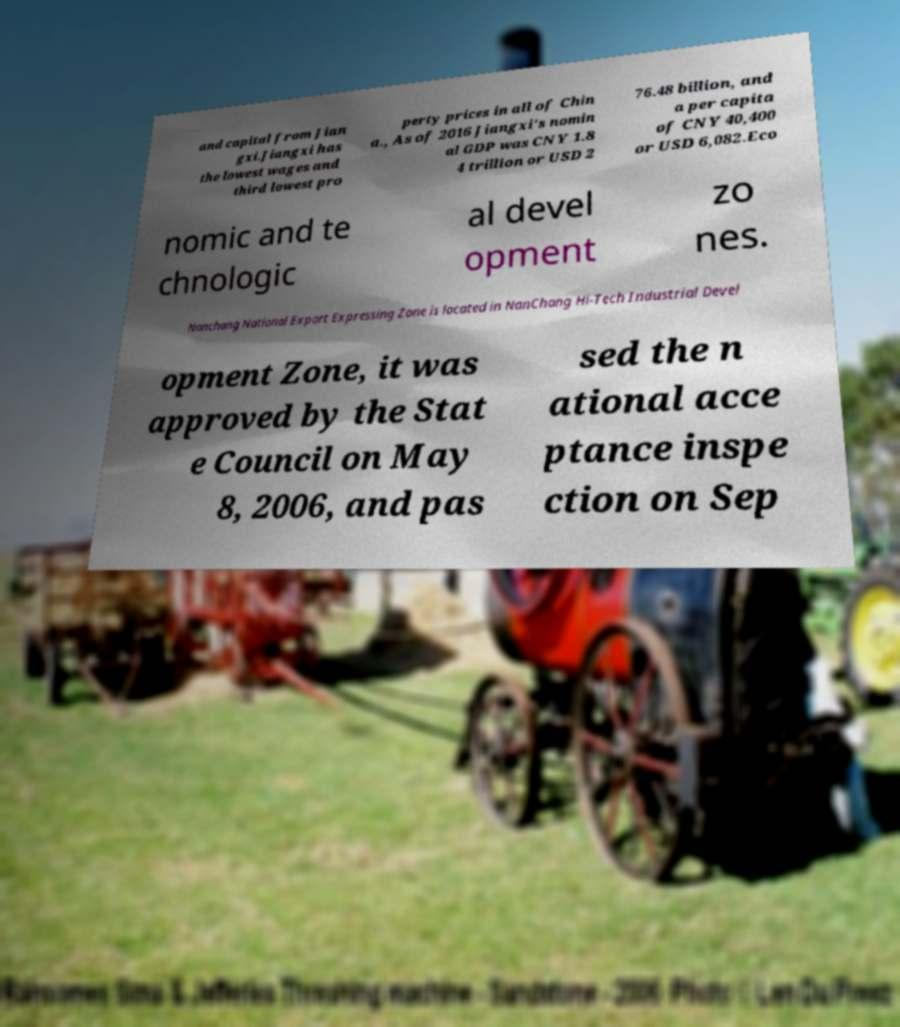Could you assist in decoding the text presented in this image and type it out clearly? and capital from Jian gxi.Jiangxi has the lowest wages and third lowest pro perty prices in all of Chin a., As of 2016 Jiangxi's nomin al GDP was CNY 1.8 4 trillion or USD 2 76.48 billion, and a per capita of CNY 40,400 or USD 6,082.Eco nomic and te chnologic al devel opment zo nes. Nanchang National Export Expressing Zone is located in NanChang Hi-Tech Industrial Devel opment Zone, it was approved by the Stat e Council on May 8, 2006, and pas sed the n ational acce ptance inspe ction on Sep 